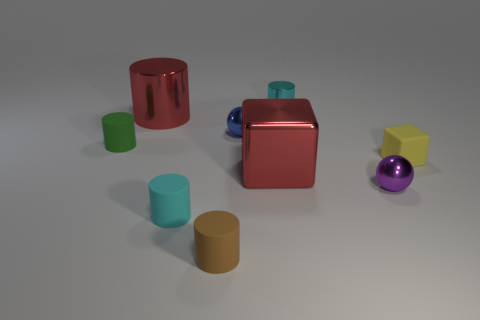What number of other tiny metallic objects have the same shape as the small yellow object?
Give a very brief answer. 0. How many tiny objects are the same color as the big cylinder?
Keep it short and to the point. 0. Is the shape of the metal thing to the left of the tiny brown thing the same as the red object that is right of the big metallic cylinder?
Your answer should be compact. No. What number of red metal blocks are to the right of the tiny metal thing that is right of the cyan cylinder that is behind the cyan rubber cylinder?
Provide a succinct answer. 0. There is a large red thing on the right side of the large red object that is behind the big metallic thing right of the brown object; what is its material?
Ensure brevity in your answer.  Metal. Is the small ball on the right side of the cyan metal cylinder made of the same material as the small blue thing?
Ensure brevity in your answer.  Yes. What number of purple blocks have the same size as the cyan metal cylinder?
Your response must be concise. 0. Are there more spheres that are behind the green cylinder than metallic cylinders that are on the left side of the big cylinder?
Give a very brief answer. Yes. Is there another thing of the same shape as the tiny purple metallic object?
Offer a very short reply. Yes. What is the size of the cyan cylinder that is to the right of the tiny metal sphere that is behind the green rubber object?
Offer a very short reply. Small. 